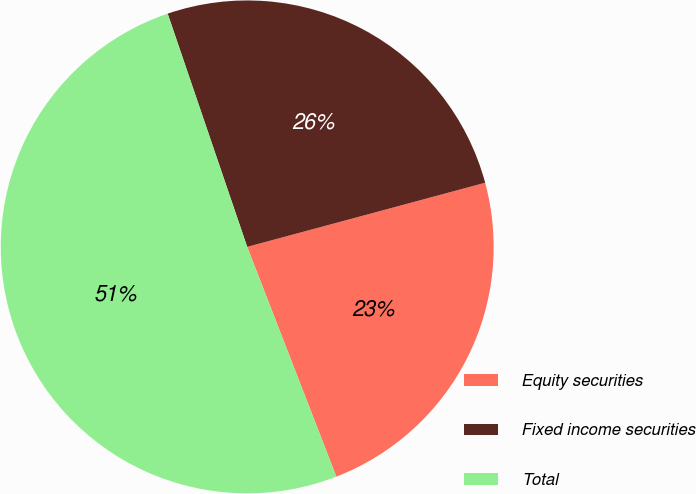Convert chart to OTSL. <chart><loc_0><loc_0><loc_500><loc_500><pie_chart><fcel>Equity securities<fcel>Fixed income securities<fcel>Total<nl><fcel>23.3%<fcel>26.04%<fcel>50.66%<nl></chart> 